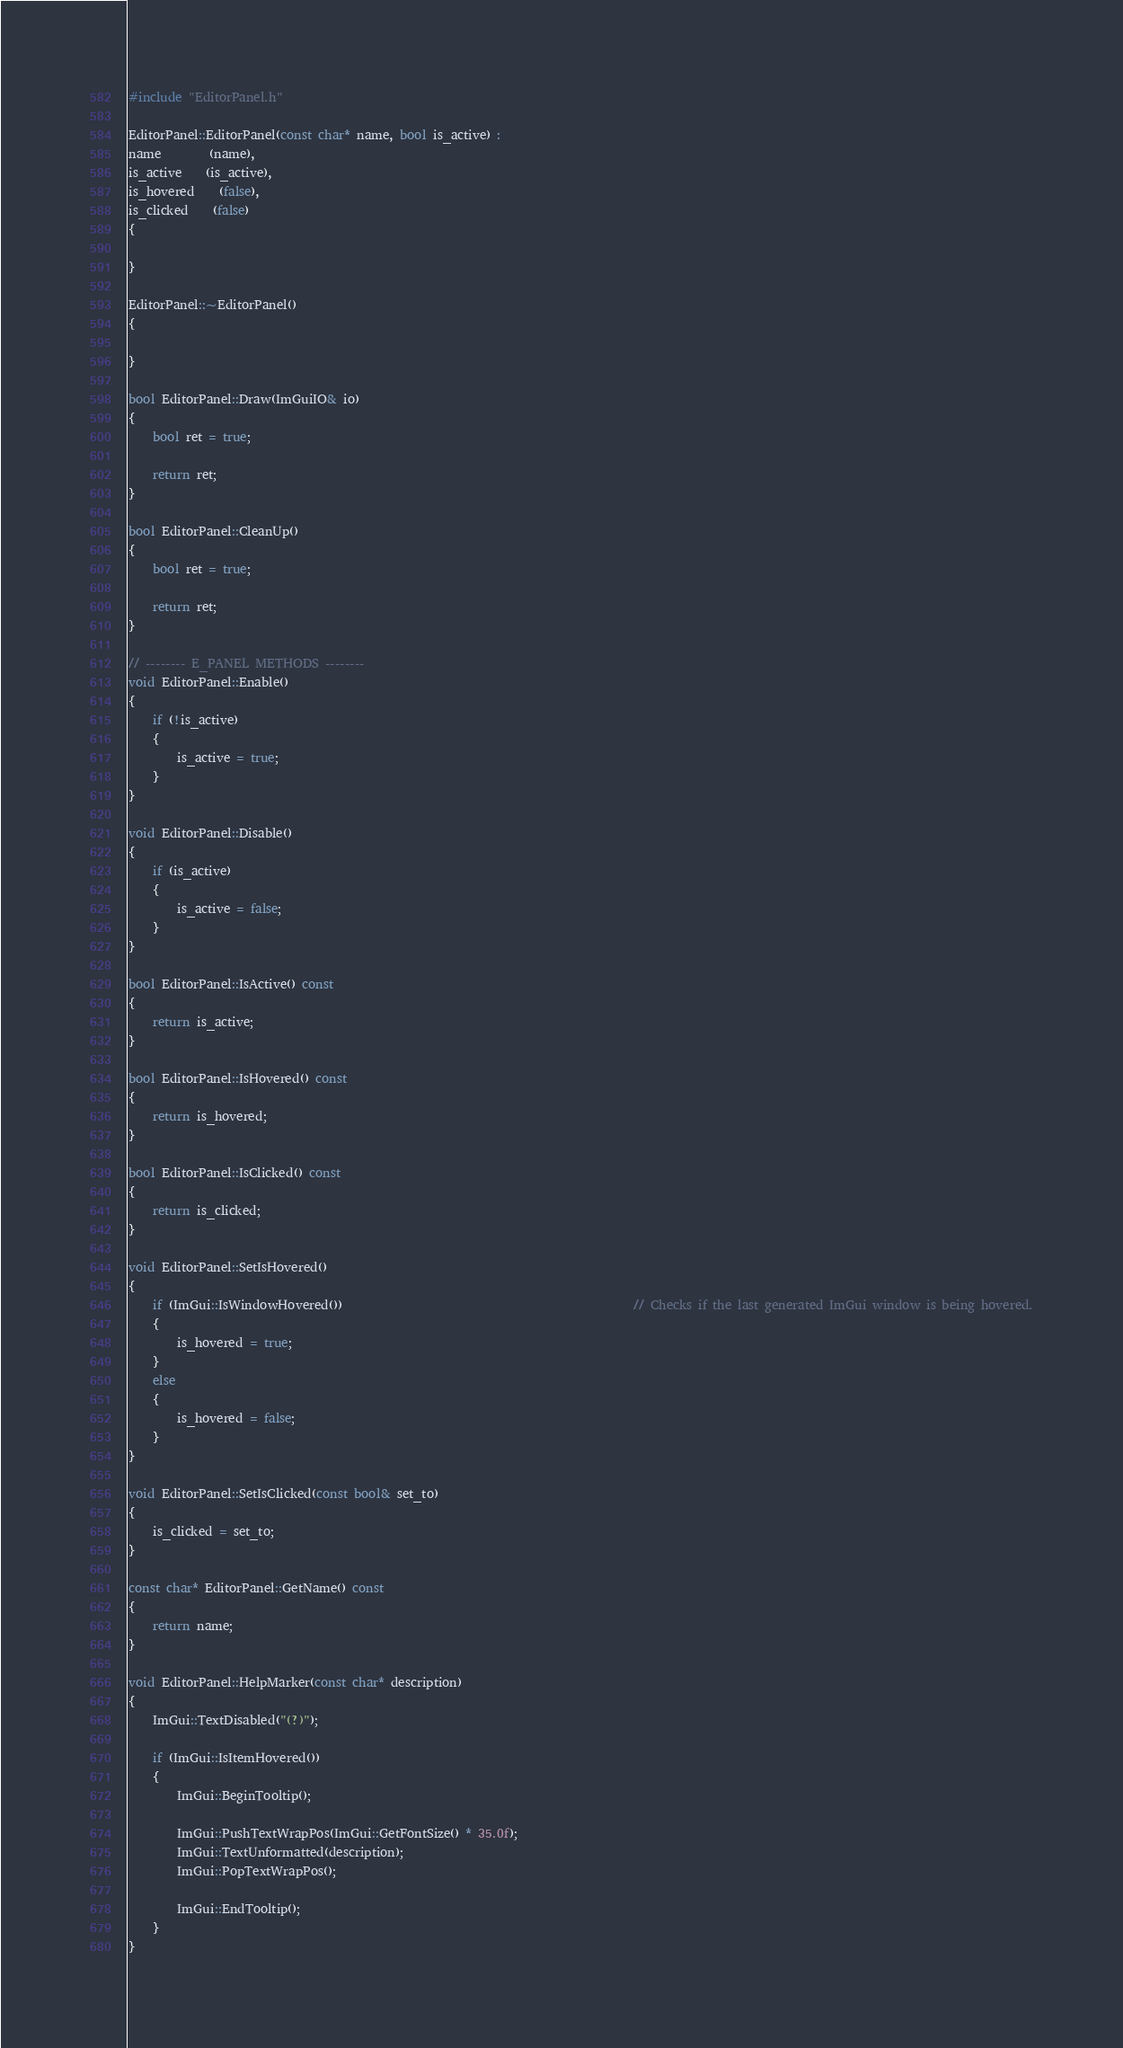<code> <loc_0><loc_0><loc_500><loc_500><_C++_>#include "EditorPanel.h"

EditorPanel::EditorPanel(const char* name, bool is_active) : 
name		(name), 
is_active	(is_active), 
is_hovered	(false),
is_clicked	(false)
{

}

EditorPanel::~EditorPanel()
{

}

bool EditorPanel::Draw(ImGuiIO& io)
{
	bool ret = true;

	return ret;
}

bool EditorPanel::CleanUp()
{
	bool ret = true;

	return ret;
}

// -------- E_PANEL METHODS --------
void EditorPanel::Enable()
{
	if (!is_active)
	{
		is_active = true;
	}
}

void EditorPanel::Disable()
{
	if (is_active)
	{
		is_active = false;
	}
}

bool EditorPanel::IsActive() const
{
	return is_active;
}

bool EditorPanel::IsHovered() const
{
	return is_hovered;
}

bool EditorPanel::IsClicked() const
{
	return is_clicked;
}

void EditorPanel::SetIsHovered()
{	
	if (ImGui::IsWindowHovered())												// Checks if the last generated ImGui window is being hovered.
	{
		is_hovered = true;
	}
	else
	{
		is_hovered = false;
	}
}

void EditorPanel::SetIsClicked(const bool& set_to)
{
	is_clicked = set_to;
}

const char* EditorPanel::GetName() const
{
	return name;
}

void EditorPanel::HelpMarker(const char* description)
{
	ImGui::TextDisabled("(?)");

	if (ImGui::IsItemHovered())
	{
		ImGui::BeginTooltip();

		ImGui::PushTextWrapPos(ImGui::GetFontSize() * 35.0f);
		ImGui::TextUnformatted(description);
		ImGui::PopTextWrapPos();

		ImGui::EndTooltip();
	}
}</code> 